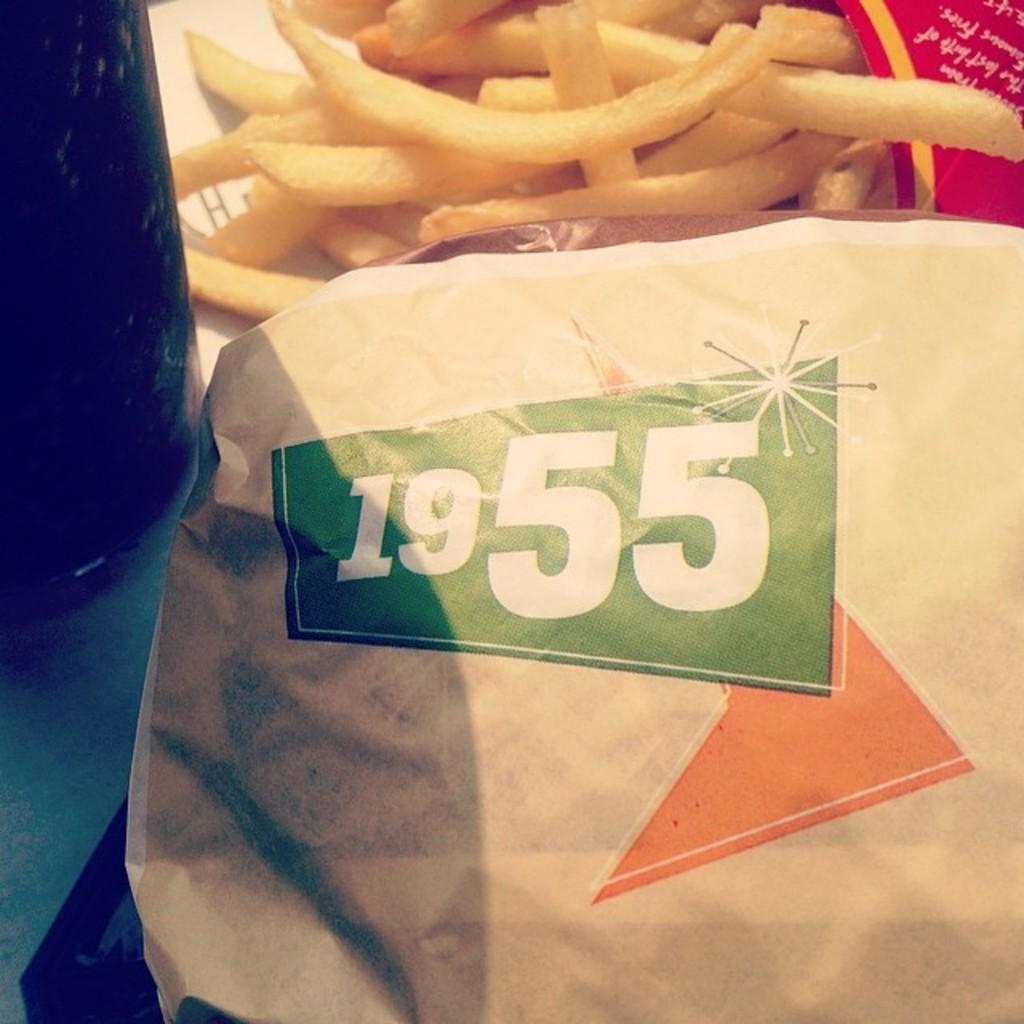How would you summarize this image in a sentence or two? In this image we can see paper, beverage bottle and french fries placed on the table. 